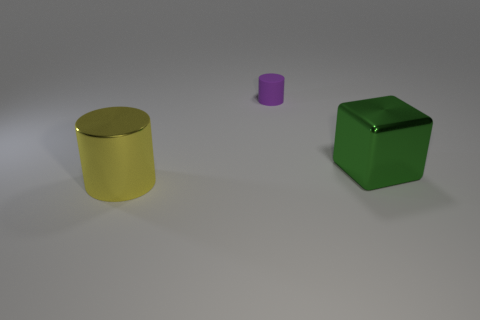The rubber cylinder is what size?
Offer a terse response. Small. How many large green shiny blocks are in front of the matte thing?
Your answer should be compact. 1. What shape is the big green object that is the same material as the big yellow object?
Make the answer very short. Cube. Is the number of green shiny cubes that are in front of the big yellow cylinder less than the number of large yellow metal things that are left of the purple rubber cylinder?
Give a very brief answer. Yes. Is the number of large blue rubber cubes greater than the number of yellow metallic cylinders?
Ensure brevity in your answer.  No. What is the material of the green block?
Your response must be concise. Metal. What is the color of the metal object right of the purple rubber thing?
Ensure brevity in your answer.  Green. Is the number of green metal cubes left of the matte cylinder greater than the number of large green blocks to the right of the green metallic cube?
Provide a short and direct response. No. What size is the thing that is on the right side of the cylinder that is behind the big metallic object behind the big cylinder?
Offer a very short reply. Large. Are there any other small cylinders that have the same color as the small matte cylinder?
Offer a very short reply. No. 